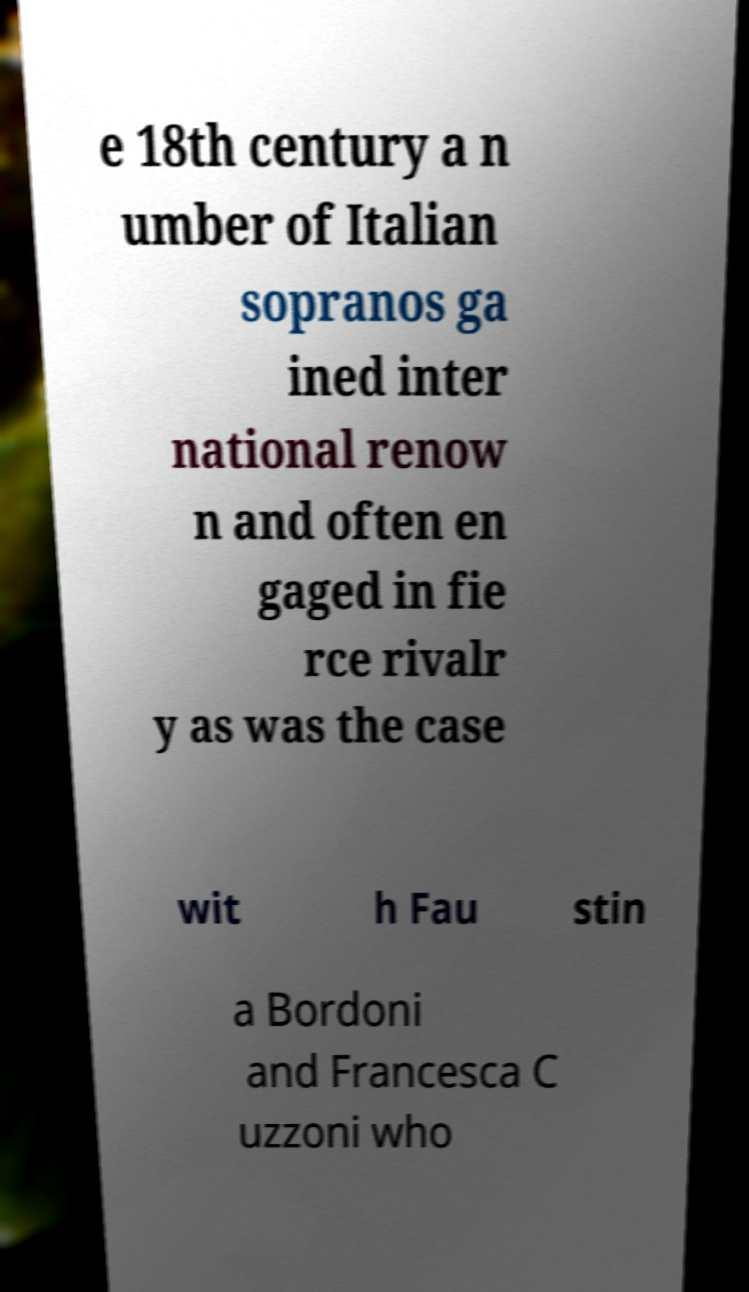I need the written content from this picture converted into text. Can you do that? e 18th century a n umber of Italian sopranos ga ined inter national renow n and often en gaged in fie rce rivalr y as was the case wit h Fau stin a Bordoni and Francesca C uzzoni who 